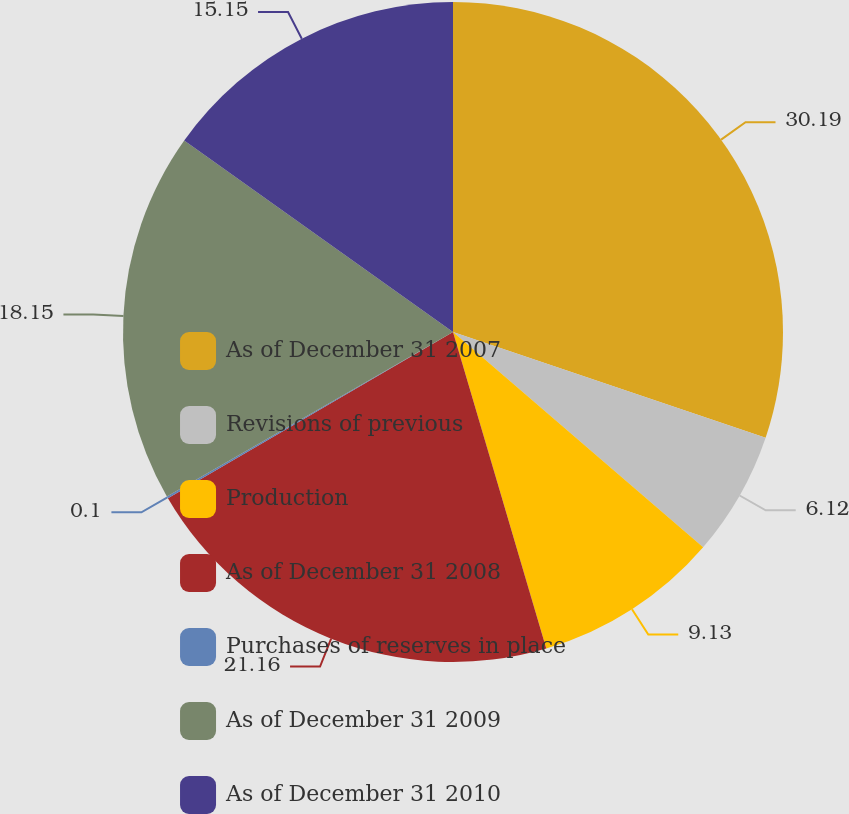<chart> <loc_0><loc_0><loc_500><loc_500><pie_chart><fcel>As of December 31 2007<fcel>Revisions of previous<fcel>Production<fcel>As of December 31 2008<fcel>Purchases of reserves in place<fcel>As of December 31 2009<fcel>As of December 31 2010<nl><fcel>30.19%<fcel>6.12%<fcel>9.13%<fcel>21.16%<fcel>0.1%<fcel>18.15%<fcel>15.15%<nl></chart> 